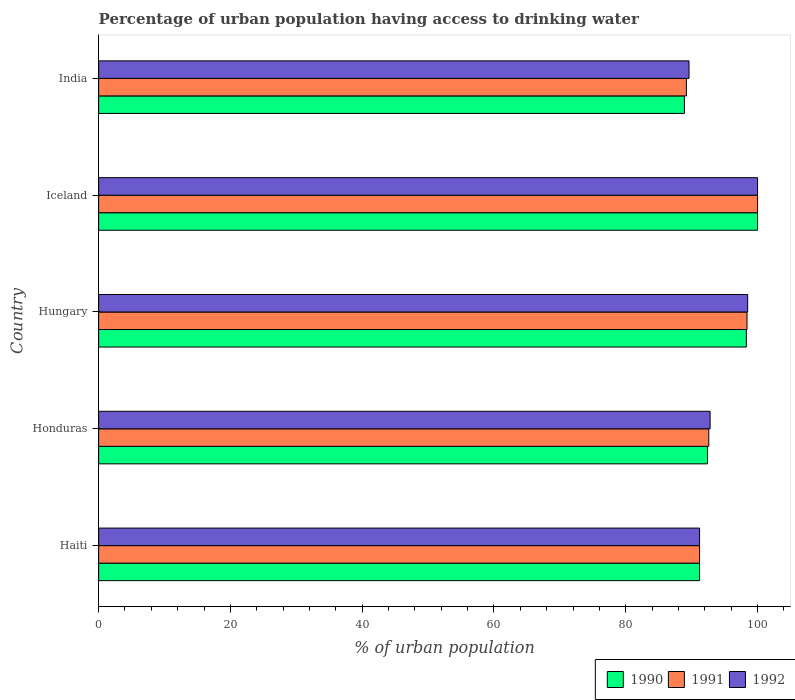How many different coloured bars are there?
Offer a very short reply. 3. Are the number of bars on each tick of the Y-axis equal?
Your answer should be very brief. Yes. How many bars are there on the 1st tick from the bottom?
Give a very brief answer. 3. What is the label of the 5th group of bars from the top?
Offer a very short reply. Haiti. In how many cases, is the number of bars for a given country not equal to the number of legend labels?
Provide a short and direct response. 0. What is the percentage of urban population having access to drinking water in 1991 in India?
Give a very brief answer. 89.2. Across all countries, what is the minimum percentage of urban population having access to drinking water in 1991?
Provide a short and direct response. 89.2. In which country was the percentage of urban population having access to drinking water in 1992 maximum?
Offer a very short reply. Iceland. In which country was the percentage of urban population having access to drinking water in 1991 minimum?
Offer a terse response. India. What is the total percentage of urban population having access to drinking water in 1992 in the graph?
Ensure brevity in your answer.  472.1. What is the difference between the percentage of urban population having access to drinking water in 1990 in Honduras and that in Iceland?
Keep it short and to the point. -7.6. What is the difference between the percentage of urban population having access to drinking water in 1991 in Honduras and the percentage of urban population having access to drinking water in 1992 in Hungary?
Your answer should be very brief. -5.9. What is the average percentage of urban population having access to drinking water in 1991 per country?
Offer a very short reply. 94.28. What is the difference between the percentage of urban population having access to drinking water in 1992 and percentage of urban population having access to drinking water in 1990 in India?
Provide a succinct answer. 0.7. In how many countries, is the percentage of urban population having access to drinking water in 1992 greater than 12 %?
Your response must be concise. 5. What is the ratio of the percentage of urban population having access to drinking water in 1992 in Hungary to that in India?
Your response must be concise. 1.1. Is the difference between the percentage of urban population having access to drinking water in 1992 in Haiti and Iceland greater than the difference between the percentage of urban population having access to drinking water in 1990 in Haiti and Iceland?
Make the answer very short. No. What is the difference between the highest and the second highest percentage of urban population having access to drinking water in 1991?
Your response must be concise. 1.6. What is the difference between the highest and the lowest percentage of urban population having access to drinking water in 1990?
Provide a short and direct response. 11.1. Is the sum of the percentage of urban population having access to drinking water in 1991 in Honduras and Iceland greater than the maximum percentage of urban population having access to drinking water in 1990 across all countries?
Offer a terse response. Yes. What does the 2nd bar from the top in Iceland represents?
Your answer should be very brief. 1991. What does the 3rd bar from the bottom in Iceland represents?
Ensure brevity in your answer.  1992. Are all the bars in the graph horizontal?
Provide a succinct answer. Yes. How many countries are there in the graph?
Give a very brief answer. 5. What is the difference between two consecutive major ticks on the X-axis?
Your answer should be very brief. 20. Does the graph contain any zero values?
Make the answer very short. No. Does the graph contain grids?
Keep it short and to the point. No. How many legend labels are there?
Keep it short and to the point. 3. What is the title of the graph?
Give a very brief answer. Percentage of urban population having access to drinking water. Does "1986" appear as one of the legend labels in the graph?
Provide a succinct answer. No. What is the label or title of the X-axis?
Your response must be concise. % of urban population. What is the % of urban population of 1990 in Haiti?
Ensure brevity in your answer.  91.2. What is the % of urban population in 1991 in Haiti?
Your response must be concise. 91.2. What is the % of urban population of 1992 in Haiti?
Provide a short and direct response. 91.2. What is the % of urban population of 1990 in Honduras?
Your answer should be very brief. 92.4. What is the % of urban population in 1991 in Honduras?
Ensure brevity in your answer.  92.6. What is the % of urban population of 1992 in Honduras?
Offer a very short reply. 92.8. What is the % of urban population in 1990 in Hungary?
Make the answer very short. 98.3. What is the % of urban population of 1991 in Hungary?
Your answer should be very brief. 98.4. What is the % of urban population in 1992 in Hungary?
Give a very brief answer. 98.5. What is the % of urban population of 1990 in Iceland?
Provide a short and direct response. 100. What is the % of urban population of 1992 in Iceland?
Ensure brevity in your answer.  100. What is the % of urban population of 1990 in India?
Provide a succinct answer. 88.9. What is the % of urban population in 1991 in India?
Offer a terse response. 89.2. What is the % of urban population in 1992 in India?
Provide a succinct answer. 89.6. Across all countries, what is the maximum % of urban population of 1991?
Provide a short and direct response. 100. Across all countries, what is the minimum % of urban population in 1990?
Keep it short and to the point. 88.9. Across all countries, what is the minimum % of urban population in 1991?
Offer a very short reply. 89.2. Across all countries, what is the minimum % of urban population of 1992?
Keep it short and to the point. 89.6. What is the total % of urban population of 1990 in the graph?
Your answer should be compact. 470.8. What is the total % of urban population of 1991 in the graph?
Offer a very short reply. 471.4. What is the total % of urban population of 1992 in the graph?
Offer a very short reply. 472.1. What is the difference between the % of urban population in 1990 in Haiti and that in Honduras?
Give a very brief answer. -1.2. What is the difference between the % of urban population of 1991 in Haiti and that in Honduras?
Make the answer very short. -1.4. What is the difference between the % of urban population in 1992 in Haiti and that in Honduras?
Offer a terse response. -1.6. What is the difference between the % of urban population in 1990 in Haiti and that in Hungary?
Your response must be concise. -7.1. What is the difference between the % of urban population in 1990 in Haiti and that in Iceland?
Your answer should be very brief. -8.8. What is the difference between the % of urban population in 1991 in Haiti and that in Iceland?
Offer a very short reply. -8.8. What is the difference between the % of urban population of 1990 in Haiti and that in India?
Your answer should be compact. 2.3. What is the difference between the % of urban population of 1990 in Honduras and that in Hungary?
Ensure brevity in your answer.  -5.9. What is the difference between the % of urban population in 1992 in Honduras and that in Hungary?
Your response must be concise. -5.7. What is the difference between the % of urban population of 1990 in Hungary and that in Iceland?
Your response must be concise. -1.7. What is the difference between the % of urban population of 1990 in Hungary and that in India?
Make the answer very short. 9.4. What is the difference between the % of urban population of 1991 in Hungary and that in India?
Your response must be concise. 9.2. What is the difference between the % of urban population in 1990 in Iceland and that in India?
Your response must be concise. 11.1. What is the difference between the % of urban population of 1992 in Iceland and that in India?
Your response must be concise. 10.4. What is the difference between the % of urban population of 1990 in Haiti and the % of urban population of 1992 in Honduras?
Keep it short and to the point. -1.6. What is the difference between the % of urban population of 1991 in Haiti and the % of urban population of 1992 in Honduras?
Ensure brevity in your answer.  -1.6. What is the difference between the % of urban population of 1990 in Haiti and the % of urban population of 1991 in Hungary?
Keep it short and to the point. -7.2. What is the difference between the % of urban population of 1990 in Haiti and the % of urban population of 1992 in Iceland?
Your response must be concise. -8.8. What is the difference between the % of urban population in 1990 in Haiti and the % of urban population in 1991 in India?
Your answer should be very brief. 2. What is the difference between the % of urban population of 1990 in Haiti and the % of urban population of 1992 in India?
Make the answer very short. 1.6. What is the difference between the % of urban population of 1991 in Haiti and the % of urban population of 1992 in India?
Offer a very short reply. 1.6. What is the difference between the % of urban population of 1990 in Honduras and the % of urban population of 1991 in Hungary?
Provide a short and direct response. -6. What is the difference between the % of urban population in 1990 in Honduras and the % of urban population in 1992 in Hungary?
Ensure brevity in your answer.  -6.1. What is the difference between the % of urban population in 1991 in Honduras and the % of urban population in 1992 in Hungary?
Make the answer very short. -5.9. What is the difference between the % of urban population in 1990 in Honduras and the % of urban population in 1991 in Iceland?
Offer a terse response. -7.6. What is the difference between the % of urban population of 1990 in Honduras and the % of urban population of 1992 in Iceland?
Your response must be concise. -7.6. What is the difference between the % of urban population in 1991 in Honduras and the % of urban population in 1992 in Iceland?
Your answer should be very brief. -7.4. What is the difference between the % of urban population of 1990 in Honduras and the % of urban population of 1991 in India?
Offer a terse response. 3.2. What is the difference between the % of urban population of 1990 in Honduras and the % of urban population of 1992 in India?
Offer a terse response. 2.8. What is the difference between the % of urban population in 1991 in Honduras and the % of urban population in 1992 in India?
Keep it short and to the point. 3. What is the difference between the % of urban population in 1990 in Hungary and the % of urban population in 1991 in Iceland?
Ensure brevity in your answer.  -1.7. What is the difference between the % of urban population of 1990 in Hungary and the % of urban population of 1991 in India?
Keep it short and to the point. 9.1. What is the difference between the % of urban population in 1990 in Hungary and the % of urban population in 1992 in India?
Your answer should be very brief. 8.7. What is the difference between the % of urban population in 1991 in Hungary and the % of urban population in 1992 in India?
Offer a terse response. 8.8. What is the difference between the % of urban population of 1990 in Iceland and the % of urban population of 1991 in India?
Ensure brevity in your answer.  10.8. What is the difference between the % of urban population of 1990 in Iceland and the % of urban population of 1992 in India?
Your answer should be very brief. 10.4. What is the difference between the % of urban population of 1991 in Iceland and the % of urban population of 1992 in India?
Give a very brief answer. 10.4. What is the average % of urban population in 1990 per country?
Give a very brief answer. 94.16. What is the average % of urban population of 1991 per country?
Your response must be concise. 94.28. What is the average % of urban population in 1992 per country?
Keep it short and to the point. 94.42. What is the difference between the % of urban population of 1990 and % of urban population of 1991 in Haiti?
Your response must be concise. 0. What is the difference between the % of urban population in 1991 and % of urban population in 1992 in Haiti?
Your answer should be very brief. 0. What is the difference between the % of urban population of 1990 and % of urban population of 1991 in Honduras?
Your response must be concise. -0.2. What is the difference between the % of urban population in 1990 and % of urban population in 1992 in Honduras?
Offer a very short reply. -0.4. What is the difference between the % of urban population in 1991 and % of urban population in 1992 in Hungary?
Keep it short and to the point. -0.1. What is the difference between the % of urban population of 1990 and % of urban population of 1992 in India?
Give a very brief answer. -0.7. What is the difference between the % of urban population in 1991 and % of urban population in 1992 in India?
Your answer should be very brief. -0.4. What is the ratio of the % of urban population of 1990 in Haiti to that in Honduras?
Give a very brief answer. 0.99. What is the ratio of the % of urban population of 1991 in Haiti to that in Honduras?
Your answer should be compact. 0.98. What is the ratio of the % of urban population in 1992 in Haiti to that in Honduras?
Ensure brevity in your answer.  0.98. What is the ratio of the % of urban population of 1990 in Haiti to that in Hungary?
Keep it short and to the point. 0.93. What is the ratio of the % of urban population in 1991 in Haiti to that in Hungary?
Provide a succinct answer. 0.93. What is the ratio of the % of urban population in 1992 in Haiti to that in Hungary?
Your answer should be very brief. 0.93. What is the ratio of the % of urban population in 1990 in Haiti to that in Iceland?
Provide a succinct answer. 0.91. What is the ratio of the % of urban population in 1991 in Haiti to that in Iceland?
Give a very brief answer. 0.91. What is the ratio of the % of urban population of 1992 in Haiti to that in Iceland?
Keep it short and to the point. 0.91. What is the ratio of the % of urban population in 1990 in Haiti to that in India?
Offer a terse response. 1.03. What is the ratio of the % of urban population of 1991 in Haiti to that in India?
Provide a short and direct response. 1.02. What is the ratio of the % of urban population of 1992 in Haiti to that in India?
Provide a short and direct response. 1.02. What is the ratio of the % of urban population in 1991 in Honduras to that in Hungary?
Offer a terse response. 0.94. What is the ratio of the % of urban population in 1992 in Honduras to that in Hungary?
Give a very brief answer. 0.94. What is the ratio of the % of urban population of 1990 in Honduras to that in Iceland?
Make the answer very short. 0.92. What is the ratio of the % of urban population of 1991 in Honduras to that in Iceland?
Provide a succinct answer. 0.93. What is the ratio of the % of urban population in 1992 in Honduras to that in Iceland?
Your answer should be compact. 0.93. What is the ratio of the % of urban population in 1990 in Honduras to that in India?
Your response must be concise. 1.04. What is the ratio of the % of urban population of 1991 in Honduras to that in India?
Offer a terse response. 1.04. What is the ratio of the % of urban population in 1992 in Honduras to that in India?
Provide a short and direct response. 1.04. What is the ratio of the % of urban population of 1990 in Hungary to that in India?
Make the answer very short. 1.11. What is the ratio of the % of urban population of 1991 in Hungary to that in India?
Give a very brief answer. 1.1. What is the ratio of the % of urban population of 1992 in Hungary to that in India?
Keep it short and to the point. 1.1. What is the ratio of the % of urban population in 1990 in Iceland to that in India?
Give a very brief answer. 1.12. What is the ratio of the % of urban population of 1991 in Iceland to that in India?
Provide a short and direct response. 1.12. What is the ratio of the % of urban population of 1992 in Iceland to that in India?
Provide a short and direct response. 1.12. What is the difference between the highest and the second highest % of urban population of 1990?
Provide a succinct answer. 1.7. What is the difference between the highest and the second highest % of urban population of 1992?
Provide a succinct answer. 1.5. What is the difference between the highest and the lowest % of urban population in 1990?
Offer a very short reply. 11.1. What is the difference between the highest and the lowest % of urban population of 1992?
Provide a short and direct response. 10.4. 